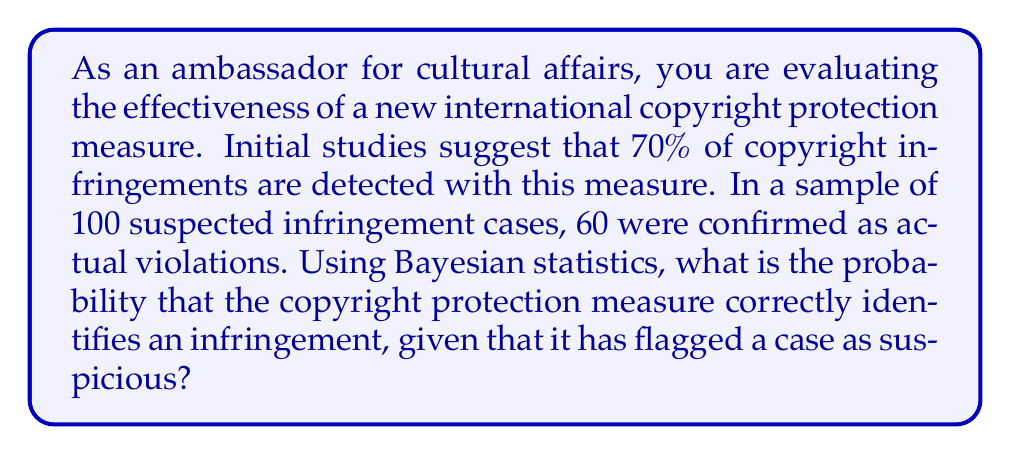Could you help me with this problem? To solve this problem using Bayesian statistics, we'll follow these steps:

1. Define the events:
   A: The case is an actual copyright infringement
   B: The copyright protection measure flags the case as suspicious

2. Given information:
   P(B|A) = 0.70 (sensitivity of the measure)
   P(A) = 60/100 = 0.60 (prior probability of infringement)

3. Calculate P(B) using the law of total probability:
   P(B) = P(B|A) * P(A) + P(B|not A) * P(not A)
   We need to estimate P(B|not A):
   P(B|not A) = (100 * 0.70 - 60 * 0.70) / (100 - 60) = 0.70

   Now we can calculate P(B):
   P(B) = 0.70 * 0.60 + 0.70 * 0.40 = 0.70

4. Apply Bayes' theorem to find P(A|B):

   $$P(A|B) = \frac{P(B|A) * P(A)}{P(B)}$$

   $$P(A|B) = \frac{0.70 * 0.60}{0.70} = 0.60$$

5. Convert to percentage:
   0.60 * 100 = 60%
Answer: 60% 